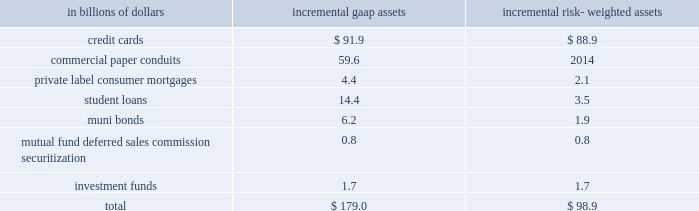Commitments .
For a further description of the loan loss reserve and related accounts , see 201cmanaging global risk 201d and notes 1 and 18 to the consolidated financial statements on pages 51 , 122 and 165 , respectively .
Securitizations the company securitizes a number of different asset classes as a means of strengthening its balance sheet and accessing competitive financing rates in the market .
Under these securitization programs , assets are sold into a trust and used as collateral by the trust to obtain financing .
The cash flows from assets in the trust service the corresponding trust securities .
If the structure of the trust meets certain accounting guidelines , trust assets are treated as sold and are no longer reflected as assets of the company .
If these guidelines are not met , the assets continue to be recorded as the company 2019s assets , with the financing activity recorded as liabilities on citigroup 2019s balance sheet .
Citigroup also assists its clients in securitizing their financial assets and packages and securitizes financial assets purchased in the financial markets .
The company may also provide administrative , asset management , underwriting , liquidity facilities and/or other services to the resulting securitization entities and may continue to service some of these financial assets .
Elimination of qspes and changes in the fin 46 ( r ) consolidation model the fasb has issued an exposure draft of a proposed standard that would eliminate qualifying special purpose entities ( qspes ) from the guidance in fasb statement no .
140 , accounting for transfers and servicing of financial assets and extinguishments of liabilities ( sfas 140 ) .
While the proposed standard has not been finalized , if it is issued in its current form it will have a significant impact on citigroup 2019s consolidated financial statements as the company will lose sales treatment for certain assets previously sold to a qspe , as well as for certain future sales , and for certain transfers of portions of assets that do not meet the proposed definition of 201cparticipating interests . 201d this proposed revision could become effective on january 1 , 2010 .
In connection with the proposed changes to sfas 140 , the fasb has also issued a separate exposure draft of a proposed standard that proposes three key changes to the consolidation model in fasb interpretation no .
46 ( revised december 2003 ) , 201cconsolidation of variable interest entities 201d ( fin 46 ( r ) ) .
First , the revised standard would include former qspes in the scope of fin 46 ( r ) .
In addition , fin 46 ( r ) would be amended to change the method of analyzing which party to a variable interest entity ( vie ) should consolidate the vie ( such consolidating entity is referred to as the 201cprimary beneficiary 201d ) to a qualitative determination of power combined with benefits or losses instead of the current risks and rewards model .
Finally , the proposed standard would require that the analysis of primary beneficiaries be re-evaluated whenever circumstances change .
The existing standard requires reconsideration only when specified reconsideration events occur .
The fasb is currently deliberating these proposed standards , and they are , accordingly , still subject to change .
Since qspes will likely be eliminated from sfas 140 and thus become subject to fin 46 ( r ) consolidation guidance and because the fin 46 ( r ) method of determining which party must consolidate a vie will likely change should this proposed standard become effective , the company expects to consolidate certain of the currently unconsolidated vies and qspes with which citigroup was involved as of december 31 , 2008 .
The company 2019s estimate of the incremental impact of adopting these changes on citigroup 2019s consolidated balance sheets and risk-weighted assets , based on december 31 , 2008 balances , our understanding of the proposed changes to the standards and a proposed january 1 , 2010 effective date , is presented below .
The actual impact of adopting the amended standards as of january 1 , 2010 could materially differ .
The pro forma impact of the proposed changes on gaap assets and risk- weighted assets , assuming application of existing risk-based capital rules , at january 1 , 2010 ( based on the balances at december 31 , 2008 ) would result in the consolidation of incremental assets as follows: .
The table reflects ( i ) the estimated portion of the assets of qspes to which citigroup , acting as principal , has transferred assets and received sales treatment as of december 31 , 2008 ( totaling approximately $ 822.1 billion ) , and ( ii ) the estimated assets of significant unconsolidated vies as of december 31 , 2008 with which citigroup is involved ( totaling approximately $ 288.0 billion ) that would be consolidated under the proposal .
Due to the variety of transaction structures and level of the company 2019s involvement in individual qspes and vies , only a subset of the qspes and vies with which the company is involved are expected to be consolidated under the proposed change .
A complete description of the company 2019s accounting for securitized assets can be found in note 1 to the consolidated financial statements on page 122. .
What percentage of incremental risk-weighted assets are student loans at january 1 , 2010? 
Computations: (3.5 / 98.9)
Answer: 0.03539. 